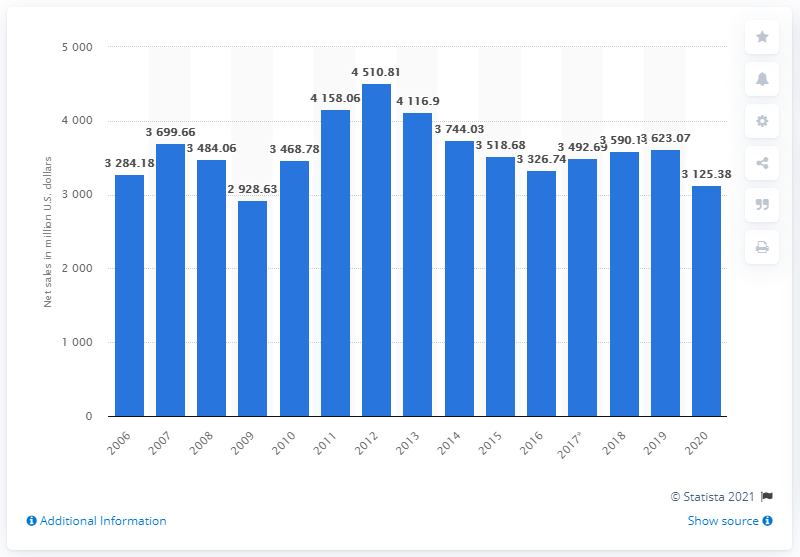List a handful of essential elements in this visual. In 2020, the net sales of Abercrombie & Fitch Co. amounted to $3125.38. The net sales of Abercrombie & Fitch Co. in the previous year were 3623.07. 